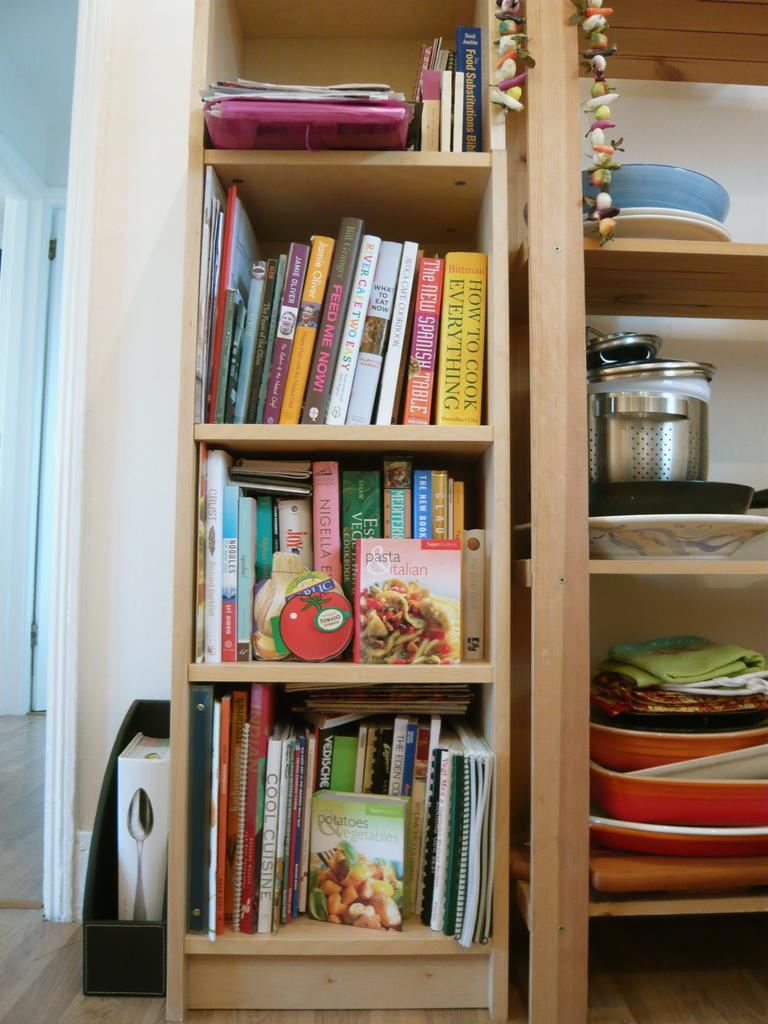What type of storage is used for the books in the image? The books are stored in wooden cupboards. What can be seen on the wooden shelf in the image? There are objects on the wooden shelf. Can you describe the other object visible in the image? There is another object visible in the image, but its description is not provided in the facts. What can be seen in the background of the image? There is another room visible in the background. What type of agreement is being discussed in the image? There is no indication of an agreement being discussed in the image; it features books in wooden cupboards and objects on a wooden shelf. What type of meat is being prepared in the image? There is no meat visible in the image; it features books in wooden cupboards and objects on a wooden shelf. 